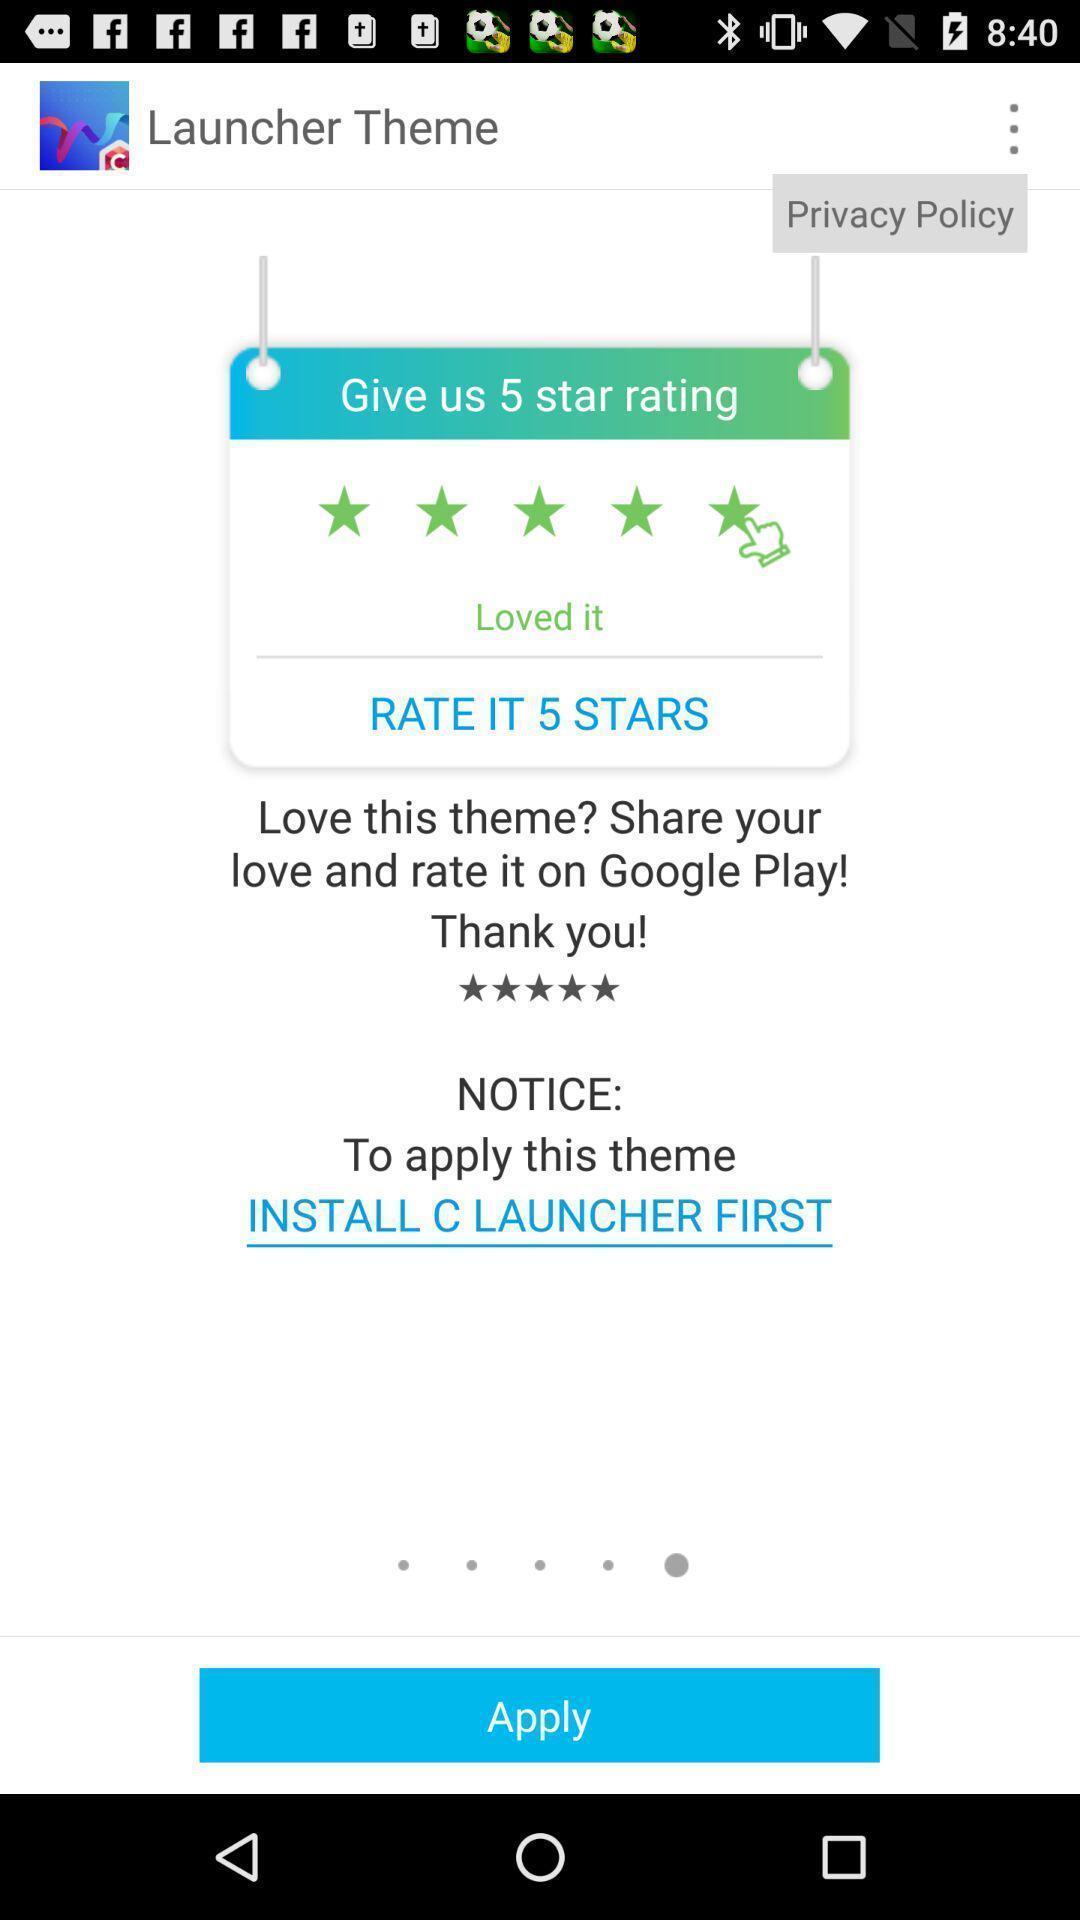Describe the visual elements of this screenshot. Page showing to rate the application. 